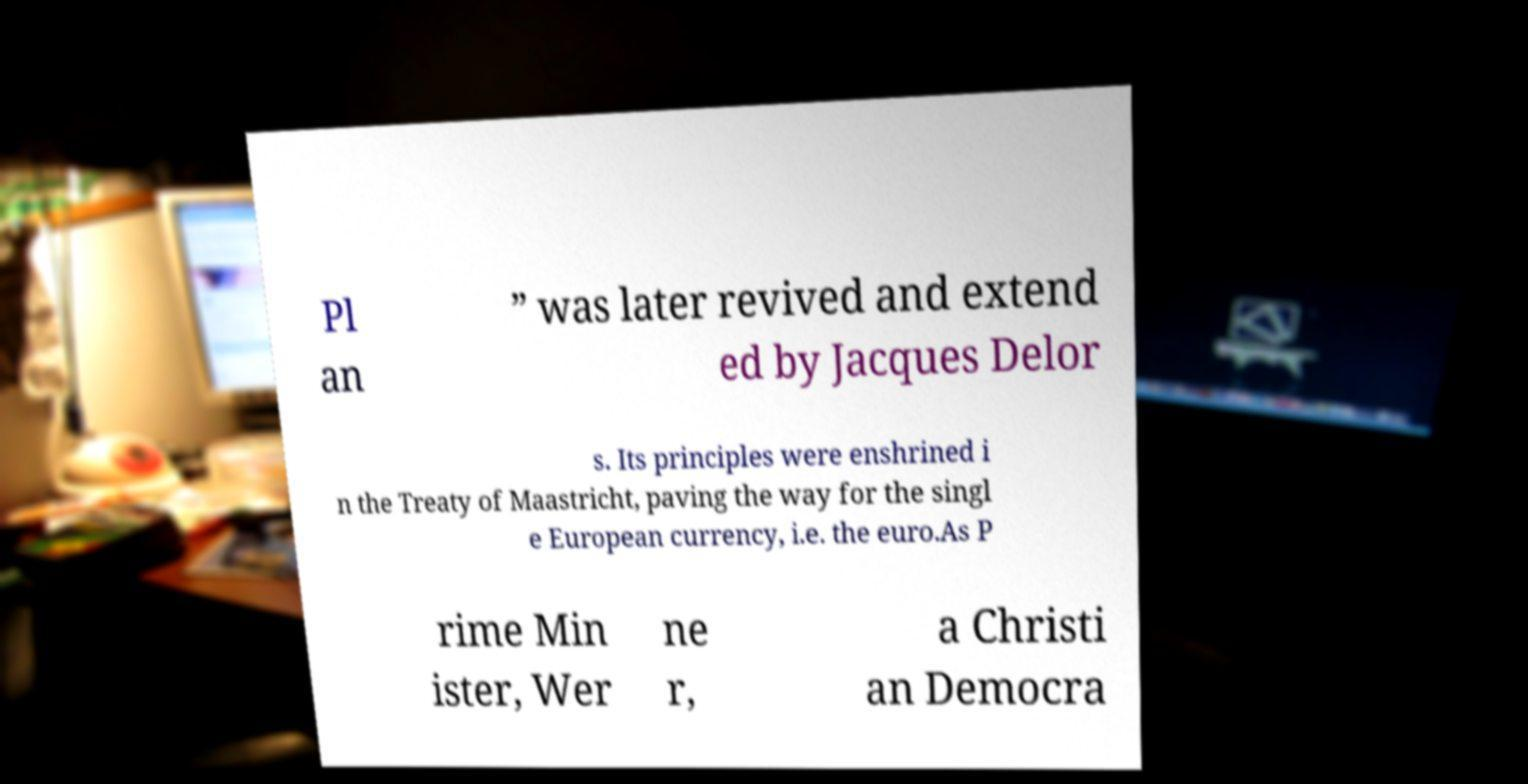What messages or text are displayed in this image? I need them in a readable, typed format. Pl an ” was later revived and extend ed by Jacques Delor s. Its principles were enshrined i n the Treaty of Maastricht, paving the way for the singl e European currency, i.e. the euro.As P rime Min ister, Wer ne r, a Christi an Democra 